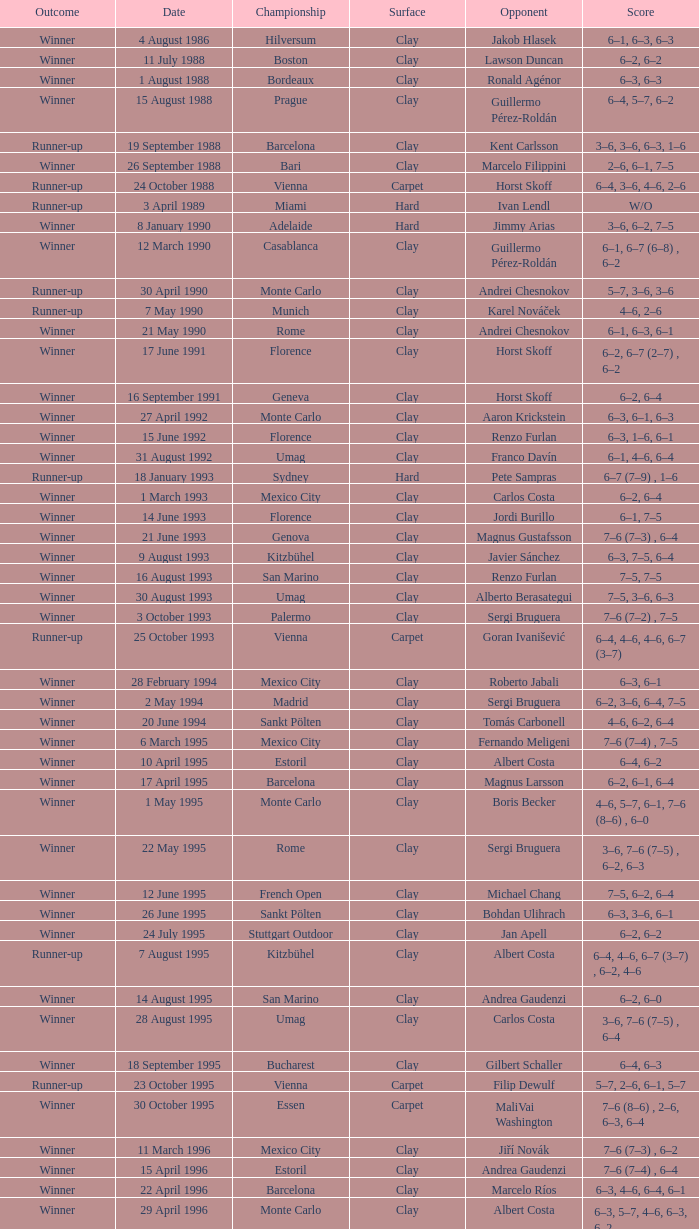When rome competes against richard krajicek in the championship, what is the current score? 6–2, 6–4, 3–6, 6–3. 